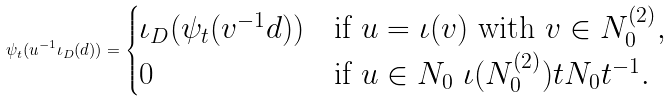<formula> <loc_0><loc_0><loc_500><loc_500>\psi _ { t } ( u ^ { - 1 } \iota _ { D } ( d ) ) = \begin{cases} \iota _ { D } ( \psi _ { t } ( v ^ { - 1 } d ) ) & \text {if $u = \iota(v)$ with $v \in N_{0}^{(2)}$} , \\ 0 & \text {if $u\in N_{0} \ \iota(N_{0}^{(2)})tN_{0}t^{-1}$} . \end{cases}</formula> 